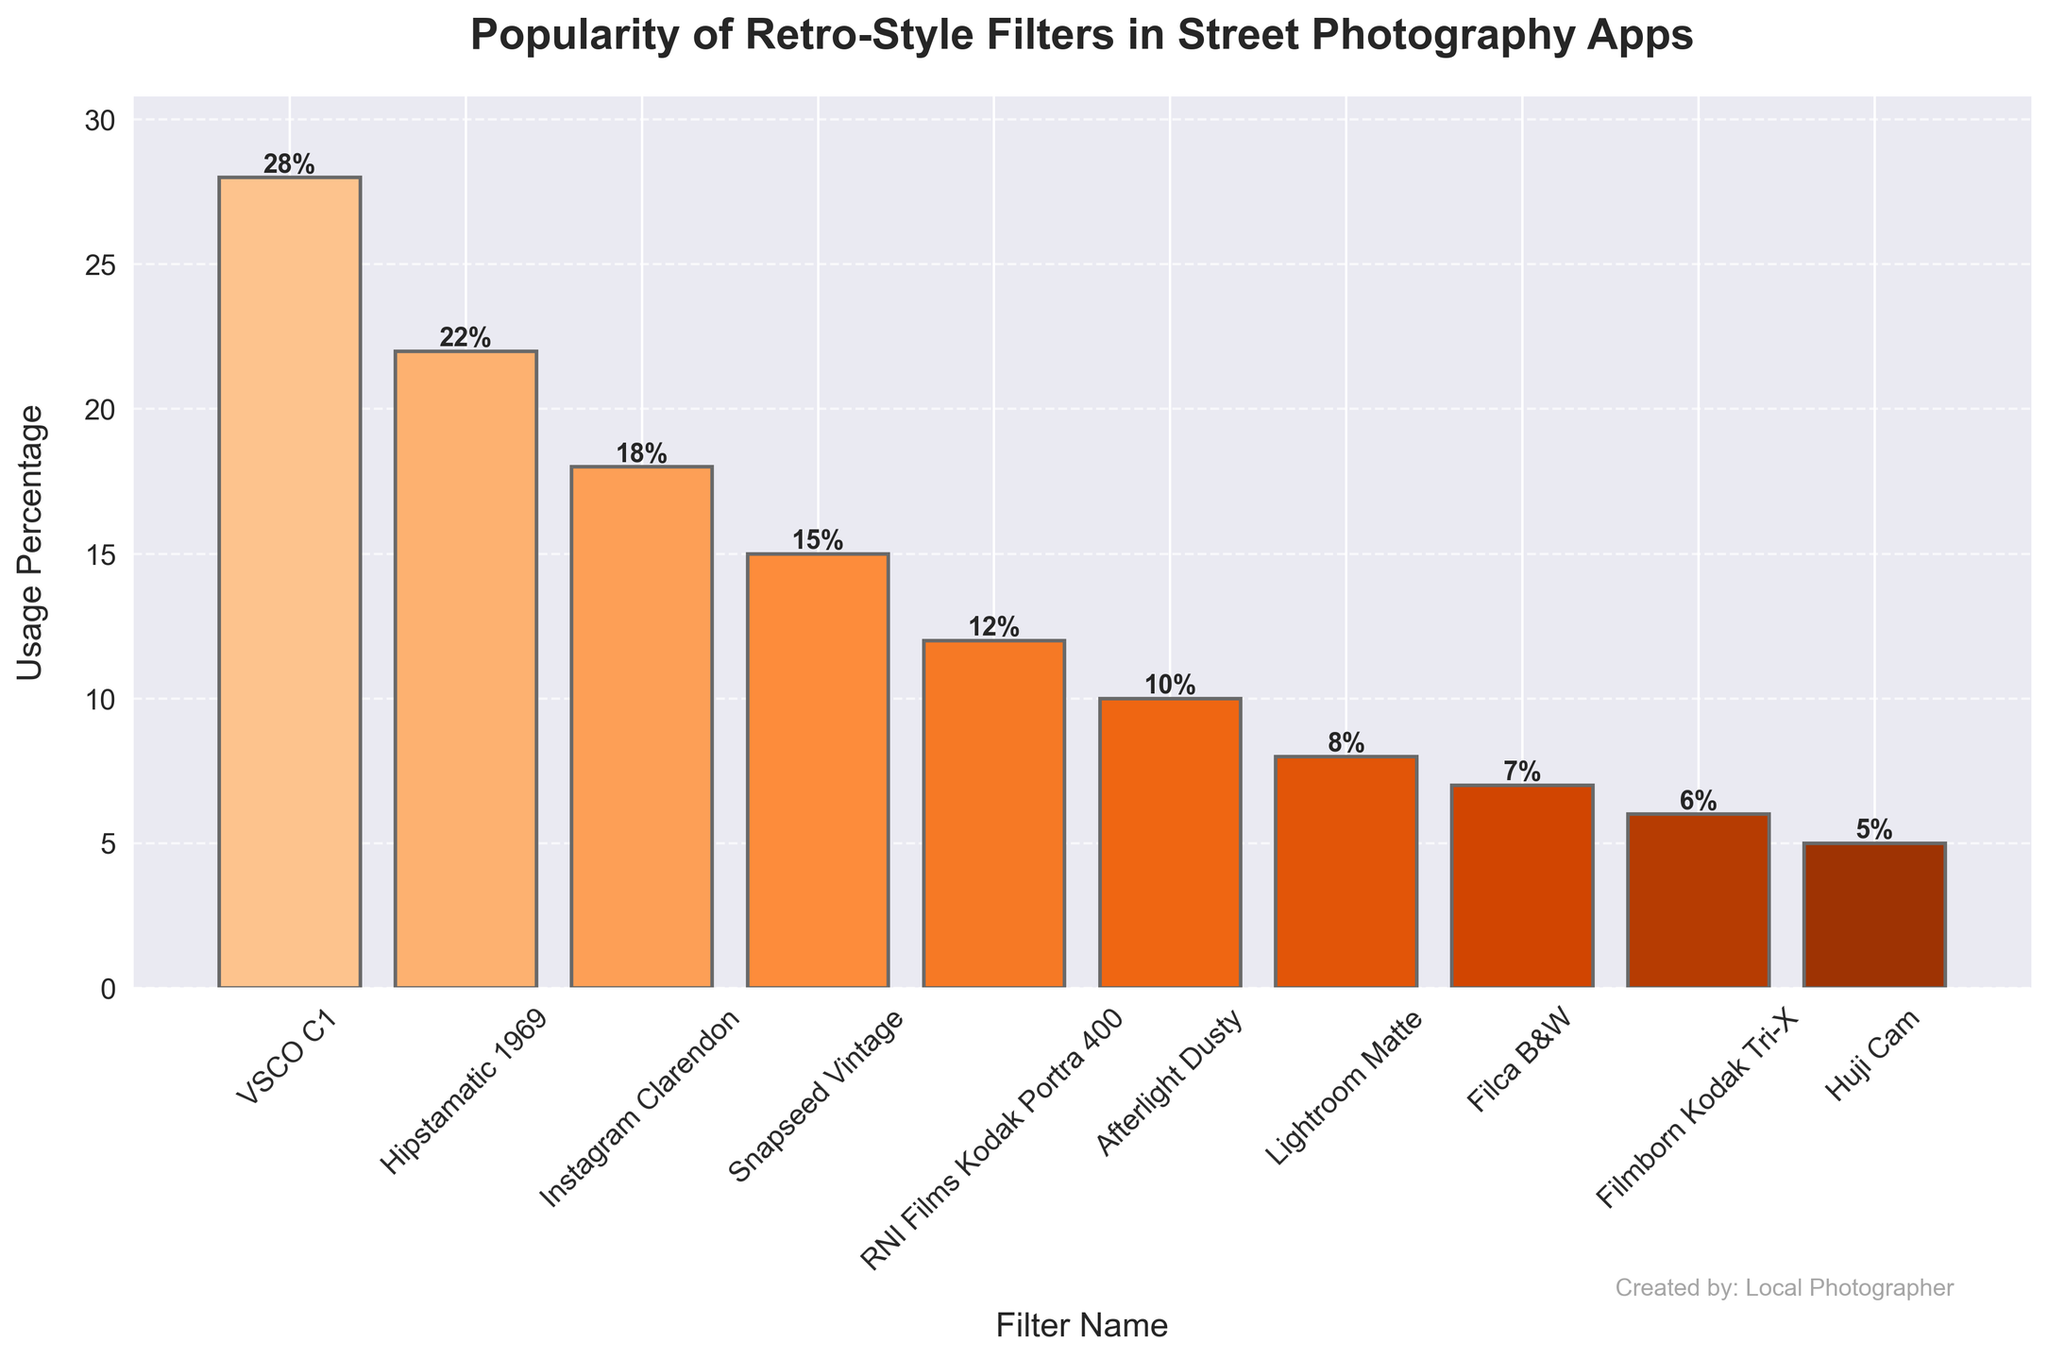Which filter is the most popular? The height of the bars in the bar chart represents the usage percentage of each filter. The tallest bar will indicate the most popular filter, which is VSCO C1 with a usage percentage of 28%.
Answer: VSCO C1 Which filter has the lowest usage percentage? The shortest bar in the bar chart shows the filter with the lowest usage percentage. Huji Cam has the shortest bar with a usage percentage of 5%.
Answer: Huji Cam What is the combined usage percentage of the top three filters? The top three filters by height/usage percentage are VSCO C1 (28%), Hipstamatic 1969 (22%), and Instagram Clarendon (18%). Adding these percentages together: 28 + 22 + 18 = 68.
Answer: 68% Which filter has a usage percentage that is 3% higher than Afterlight Dusty? First, find the usage percentage of Afterlight Dusty, which is 10%. Adding 3% to this gives 10 + 3 = 13%. Since the filter RNI Films Kodak Portra 400 has a usage percentage of 12%, there's no exact match, but it is the closest higher value.
Answer: RNI Films Kodak Portra 400 How many filters have a usage percentage greater than 15%? By examining the heights of the bars, the filters with usage percentages greater than 15% are VSCO C1, Hipstamatic 1969, and Instagram Clarendon. There are 3 such filters.
Answer: 3 Which filters have a usage percentage less than 10%? The bars with heights representing usage percentages less than 10% are Lightroom Matte (8%), Filca B&W (7%), Filmborn Kodak Tri-X (6%), and Huji Cam (5%). This gives us four filters.
Answer: 4 How much more popular is VSCO C1 compared to Snapseed Vintage? The usage percentage of VSCO C1 is 28%, and for Snapseed Vintage, it is 15%. The difference between these two percentages is calculated as 28 - 15 = 13%.
Answer: 13% What is the average usage percentage of all the filters? To find the average, sum the usage percentages for all 10 filters: 28 + 22 + 18 + 15 + 12 + 10 + 8 + 7 + 6 + 5 = 131. Then, divide by the number of filters: 131 / 10 = 13.1%.
Answer: 13.1% What is the total usage percentage of filters that have “Kodak” in their name? The filters with "Kodak" in their name are RNI Films Kodak Portra 400 (12%) and Filmborn Kodak Tri-X (6%). Adding these together: 12 + 6 = 18%.
Answer: 18% Which filter has a usage percentage exactly the midpoint of the highest and lowest usage percentages? The highest usage percentage is 28%, and the lowest is 5%. The midpoint is calculated as (28 + 5) / 2 = 16.5%. No filter has exactly 16.5%, but the closest is Snapseed Vintage with 15%.
Answer: Snapseed Vintage 